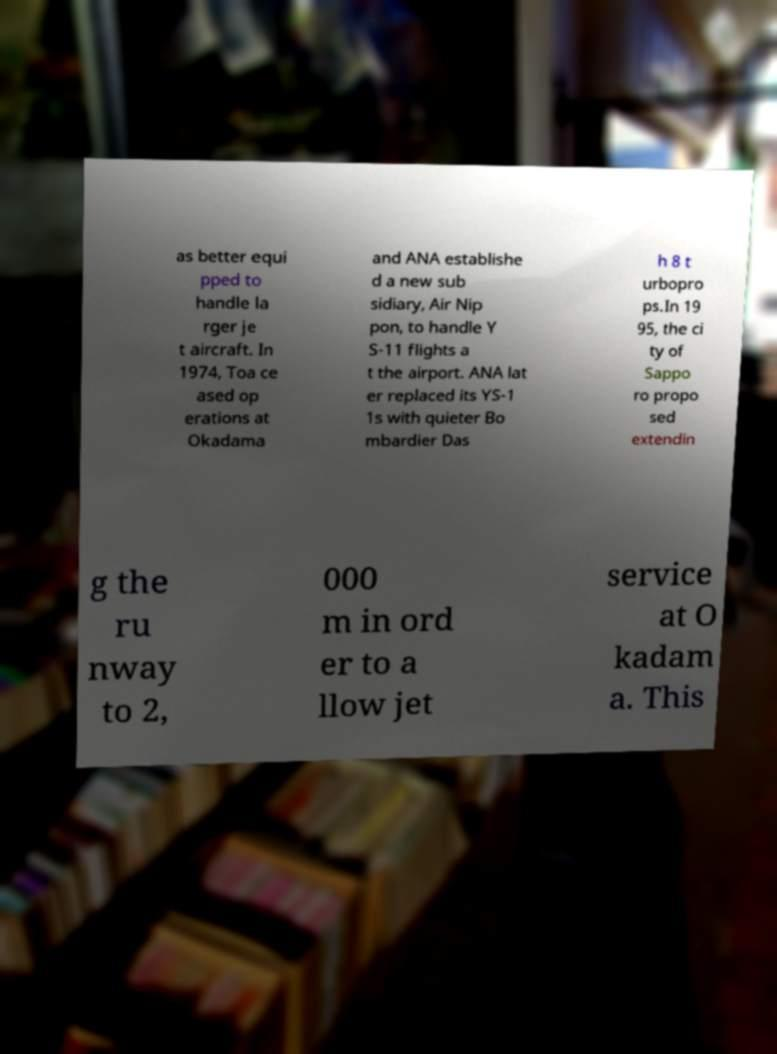Please identify and transcribe the text found in this image. as better equi pped to handle la rger je t aircraft. In 1974, Toa ce ased op erations at Okadama and ANA establishe d a new sub sidiary, Air Nip pon, to handle Y S-11 flights a t the airport. ANA lat er replaced its YS-1 1s with quieter Bo mbardier Das h 8 t urbopro ps.In 19 95, the ci ty of Sappo ro propo sed extendin g the ru nway to 2, 000 m in ord er to a llow jet service at O kadam a. This 